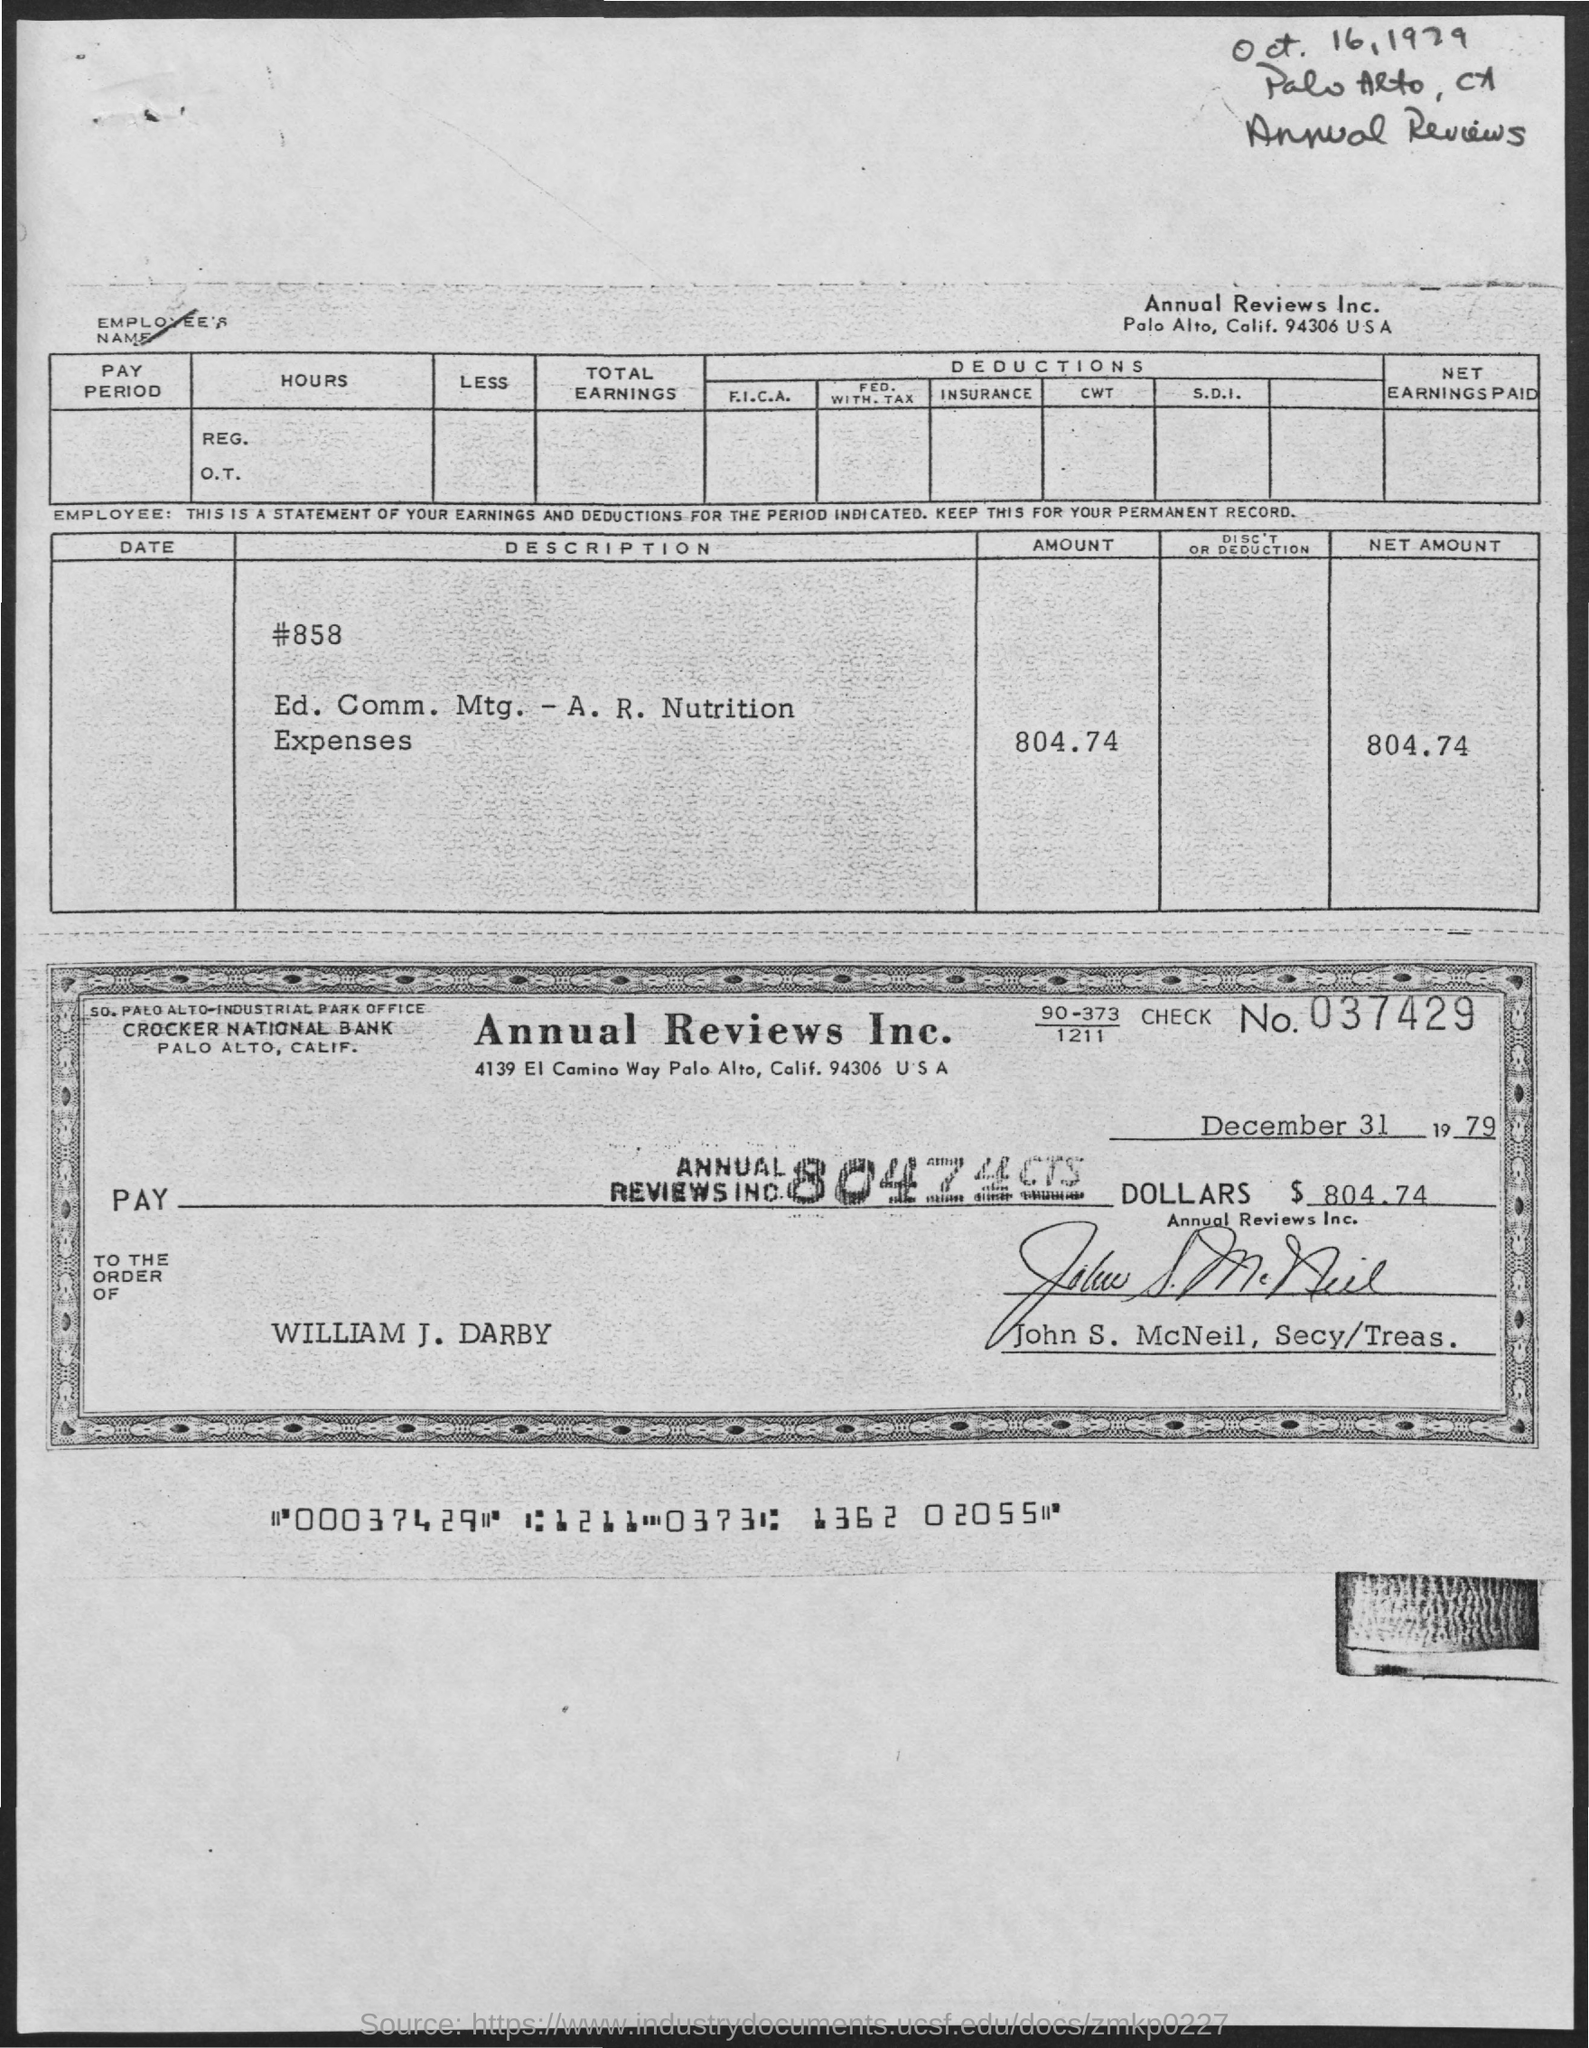What is the address of annual reviews inc.?
Your answer should be very brief. Palo Alto, Calif. 94306 USA. What is the check no.?
Provide a succinct answer. 037429. What is the date mentioned in the check?
Give a very brief answer. December 31 1979. What is the address of crocker national bank?
Make the answer very short. Palo Alto, Calif. To whose order is the check is paid ?
Your response must be concise. William J. Darby. 